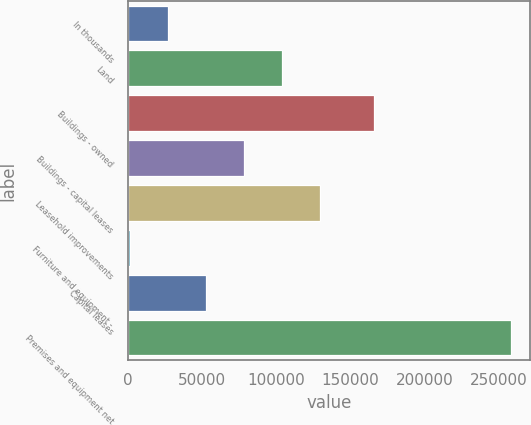Convert chart to OTSL. <chart><loc_0><loc_0><loc_500><loc_500><bar_chart><fcel>In thousands<fcel>Land<fcel>Buildings - owned<fcel>Buildings - capital leases<fcel>Leasehold improvements<fcel>Furniture and equipment -<fcel>Capital leases<fcel>Premises and equipment net<nl><fcel>26677.7<fcel>103777<fcel>165638<fcel>78077.1<fcel>129476<fcel>978<fcel>52377.4<fcel>257975<nl></chart> 